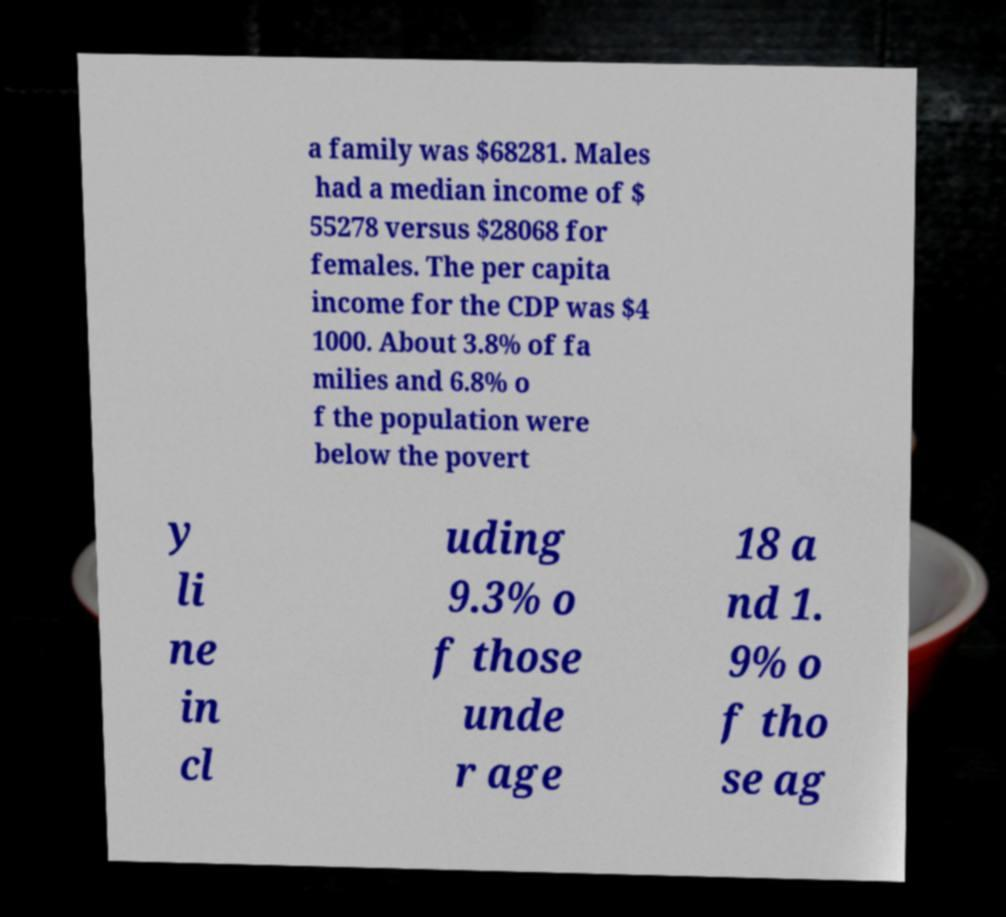Please read and relay the text visible in this image. What does it say? a family was $68281. Males had a median income of $ 55278 versus $28068 for females. The per capita income for the CDP was $4 1000. About 3.8% of fa milies and 6.8% o f the population were below the povert y li ne in cl uding 9.3% o f those unde r age 18 a nd 1. 9% o f tho se ag 